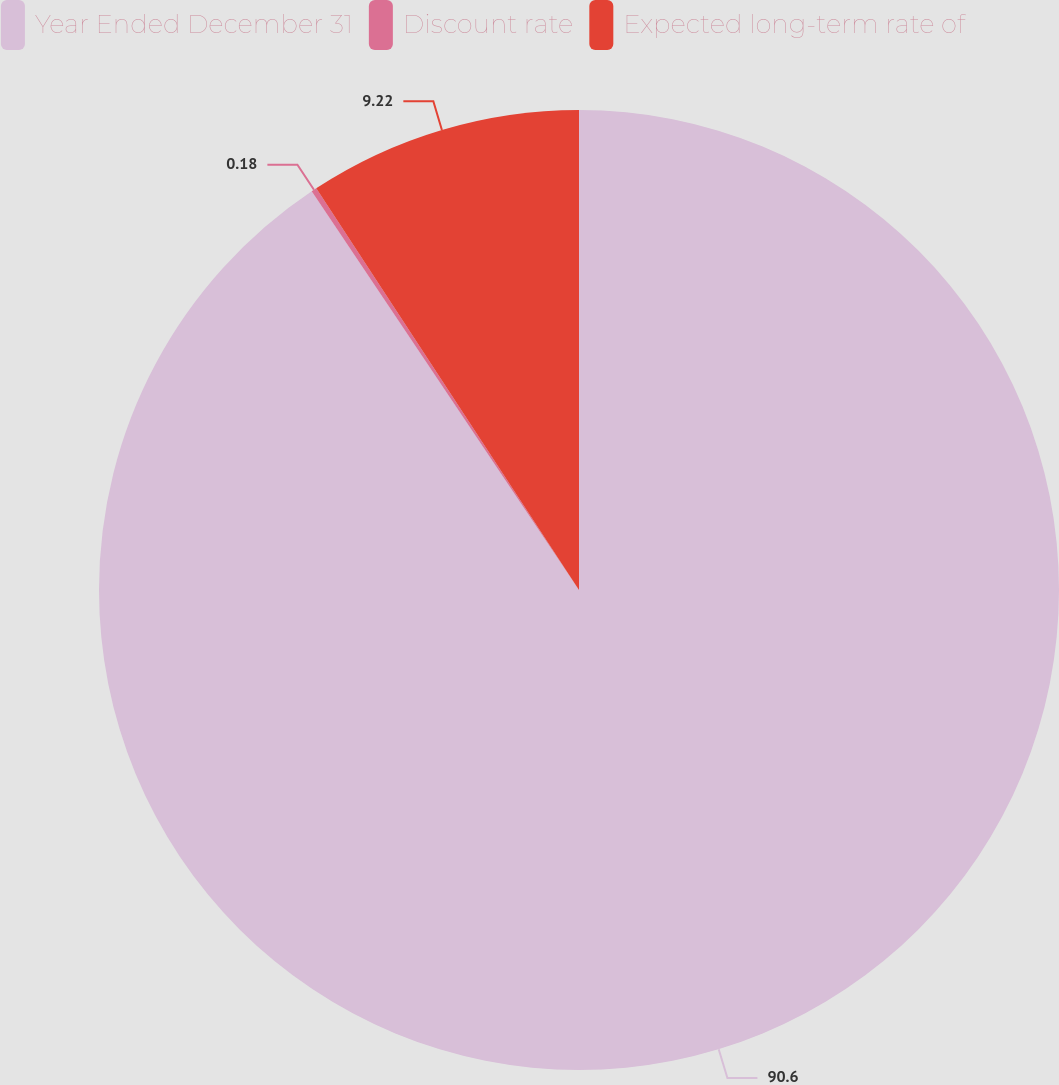<chart> <loc_0><loc_0><loc_500><loc_500><pie_chart><fcel>Year Ended December 31<fcel>Discount rate<fcel>Expected long-term rate of<nl><fcel>90.6%<fcel>0.18%<fcel>9.22%<nl></chart> 